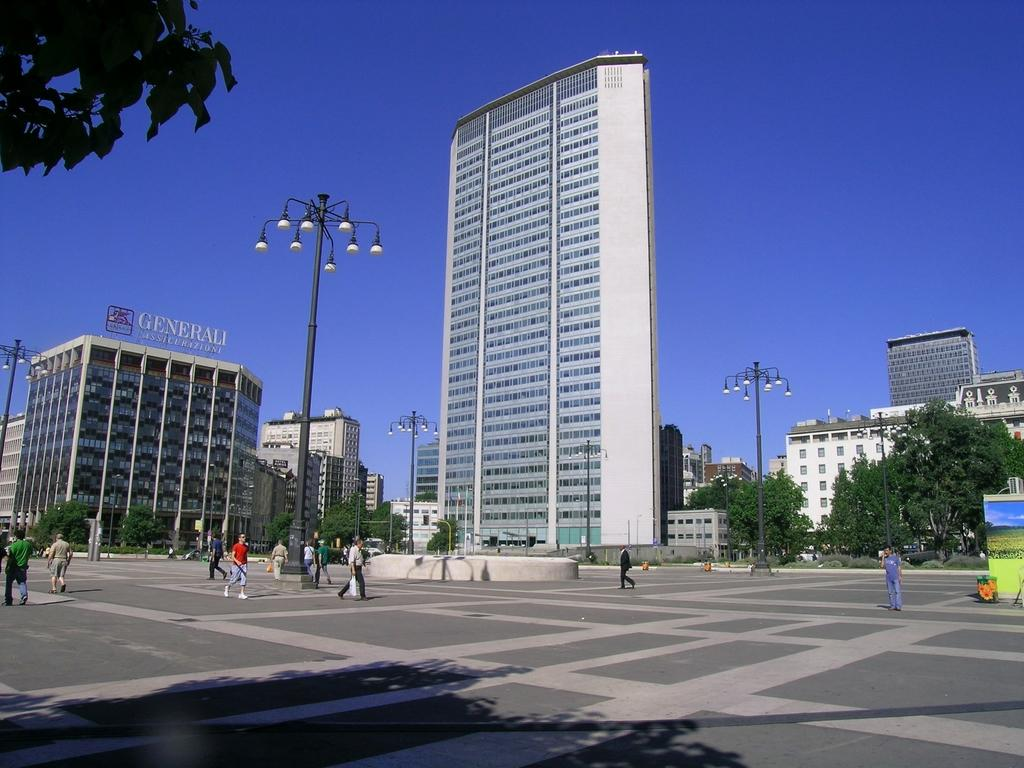What type of structures can be seen in the image? There are many buildings in the image. What other natural elements are present in the image? There are trees in the image. Are there any man-made objects that provide illumination in the image? Yes, there are poles with lights in the image. Can you describe the people in the image? There are people in the image. What is visible in the background of the image? The sky is visible in the background of the image. Where can leaves be found in the image? Leaves are present in the left side top corner of the image. What type of nerve is being treated by the doctor in the image? There is no doctor or nerve present in the image. What happens when the balloon bursts in the image? There is no balloon or bursting event present in the image. 